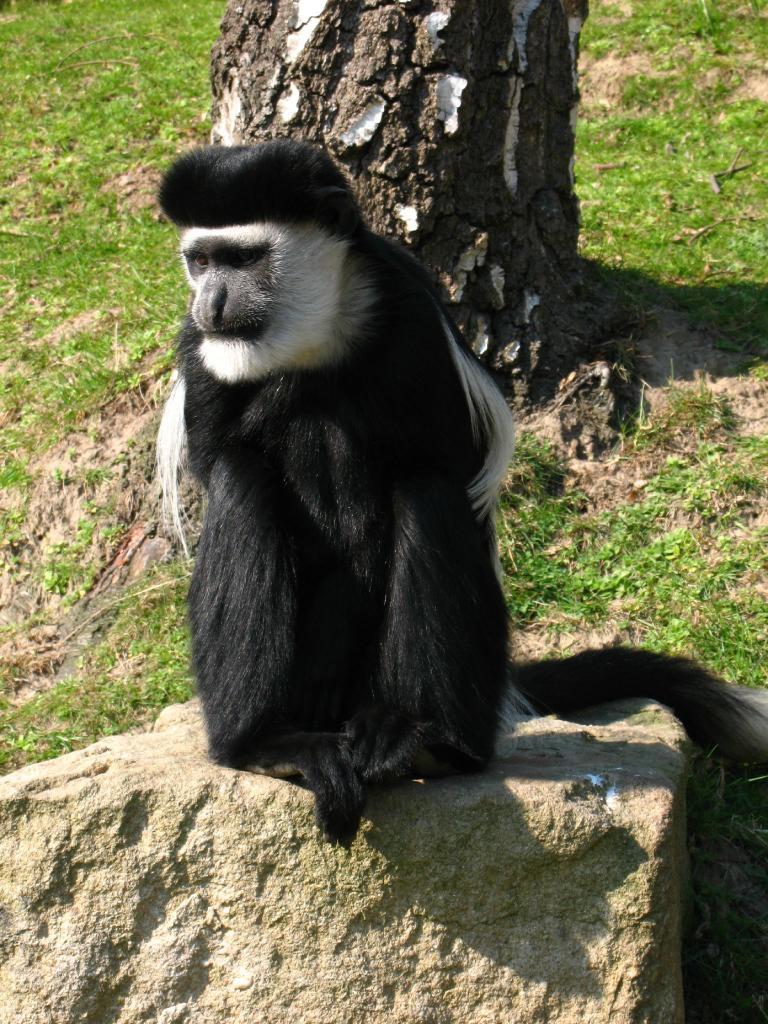Please provide a concise description of this image. In this image I can see a stone and on it I can see a black and white colour monkey. In the background I can see grass and a tree trunk. 